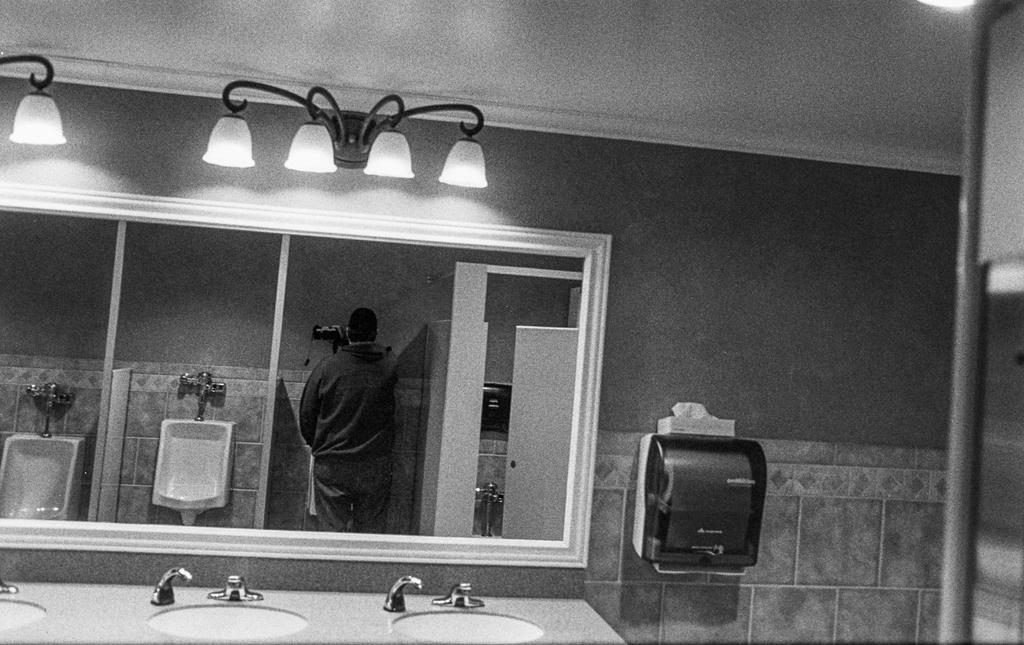What type of fixtures can be seen in the image? There are taps and sinks in the image. What other facilities are present in the image? There are toilets in the image. What is used for personal grooming in the image? There is a mirror in the image. Who is present in the image? There is a person standing in the image. What provides illumination in the image? There are lights in the image. What other objects can be seen in the image? There are some objects in the image. What can be seen in the background of the image? There is a wall in the background of the image. What type of bait is being used to catch fish in the image? There is no fishing or bait present in the image; it features a person in a room with fixtures and facilities. What type of coal is being used to heat the room in the image? There is no coal or heating element present in the image; it features a person in a room with fixtures and facilities. 